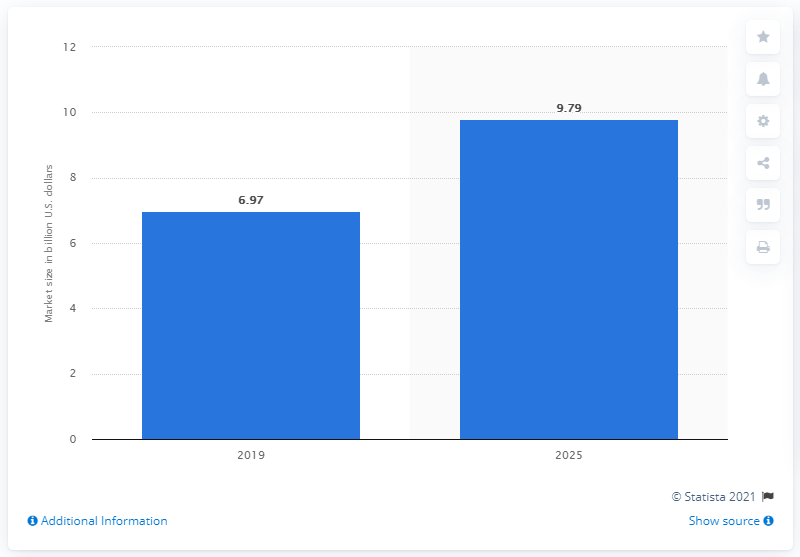Outline some significant characteristics in this image. According to the forecast, the global market for pharmaceutical excipients is expected to be worth a certain amount in the year 2025. The estimated value of the pharmaceutical excipients market in dollars in 2025 is projected to be approximately 9.79. 